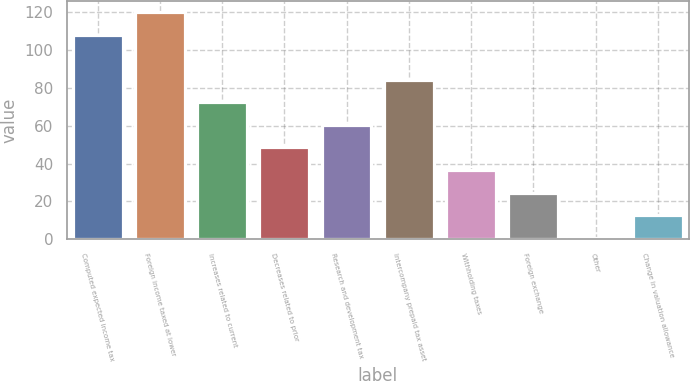Convert chart. <chart><loc_0><loc_0><loc_500><loc_500><bar_chart><fcel>Computed expected income tax<fcel>Foreign income taxed at lower<fcel>Increases related to current<fcel>Decreases related to prior<fcel>Research and development tax<fcel>Intercompany prepaid tax asset<fcel>Withholding taxes<fcel>Foreign exchange<fcel>Other<fcel>Change in valuation allowance<nl><fcel>108.18<fcel>120.1<fcel>72.42<fcel>48.58<fcel>60.5<fcel>84.34<fcel>36.66<fcel>24.74<fcel>0.9<fcel>12.82<nl></chart> 